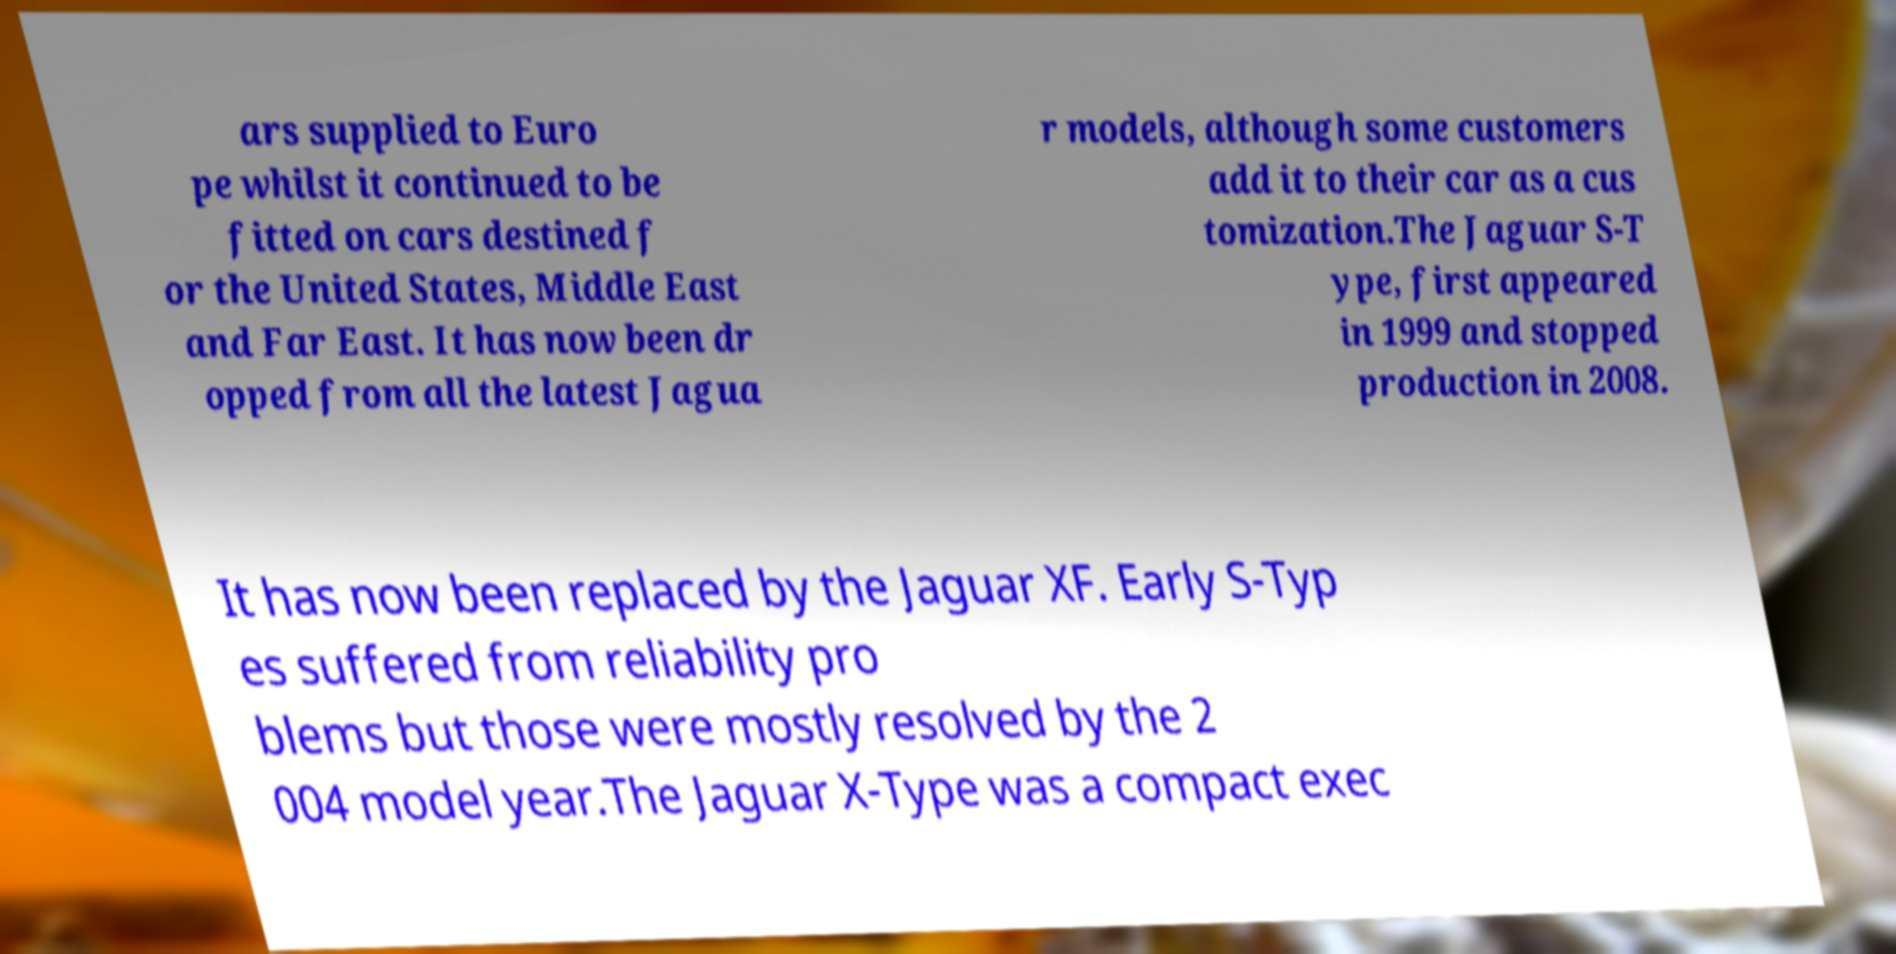Can you accurately transcribe the text from the provided image for me? ars supplied to Euro pe whilst it continued to be fitted on cars destined f or the United States, Middle East and Far East. It has now been dr opped from all the latest Jagua r models, although some customers add it to their car as a cus tomization.The Jaguar S-T ype, first appeared in 1999 and stopped production in 2008. It has now been replaced by the Jaguar XF. Early S-Typ es suffered from reliability pro blems but those were mostly resolved by the 2 004 model year.The Jaguar X-Type was a compact exec 